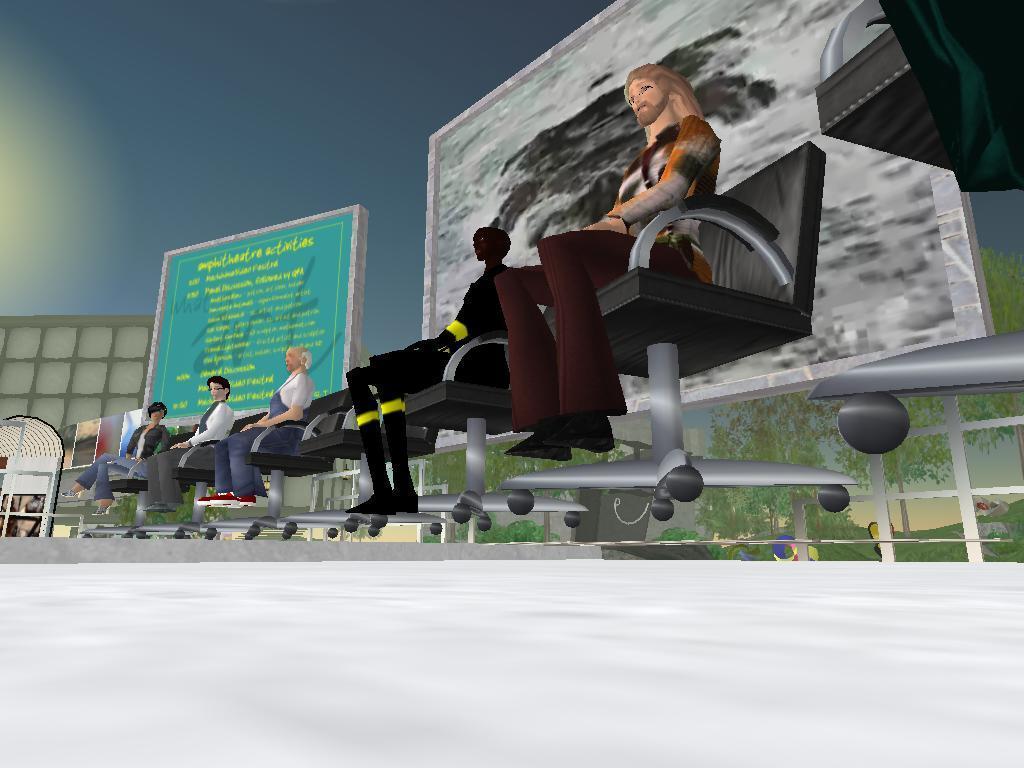How would you summarize this image in a sentence or two? This is animated picture,There are people sitting on chairs. In the background we can see screens,trees and sky. 